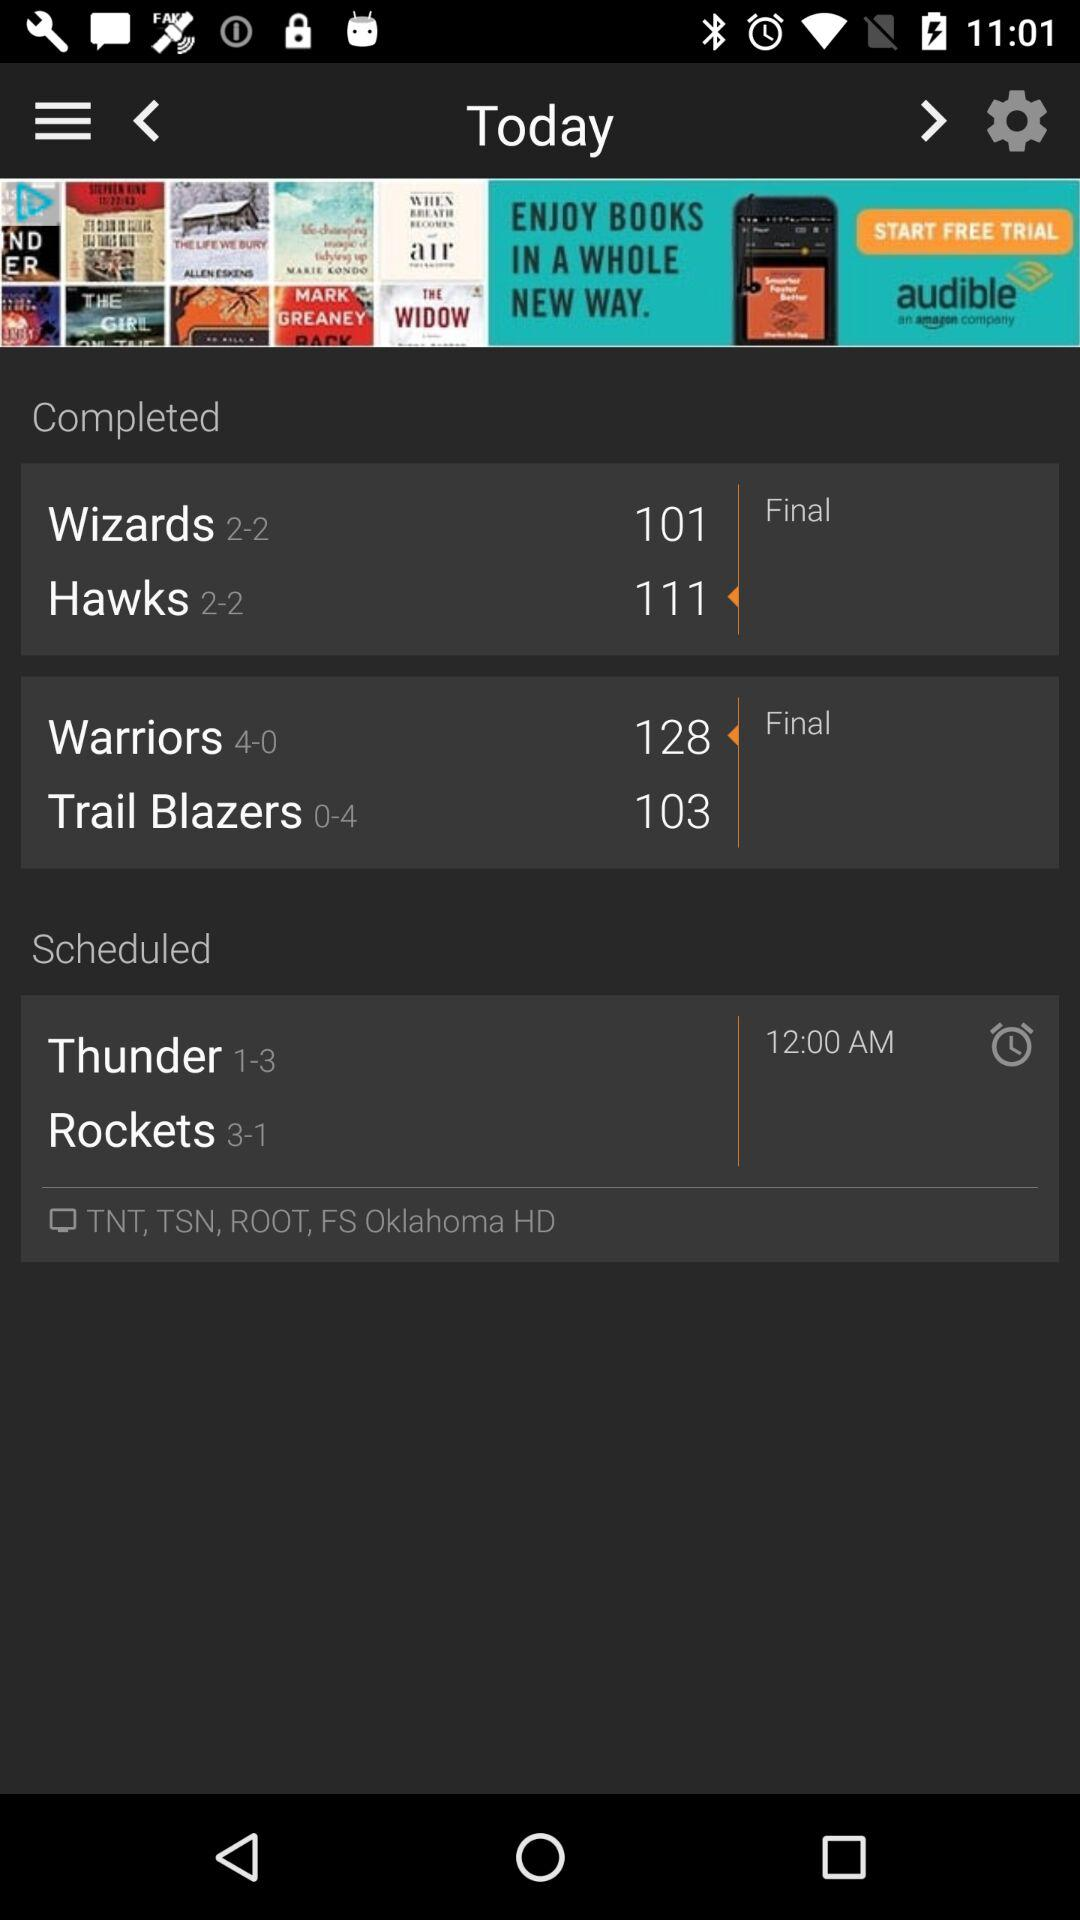How many total "Hawks" are present? A total of 111 "Hawks" are present. 